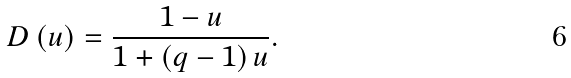<formula> <loc_0><loc_0><loc_500><loc_500>D \left ( u \right ) = \frac { 1 - u } { 1 + \left ( q - 1 \right ) u } .</formula> 